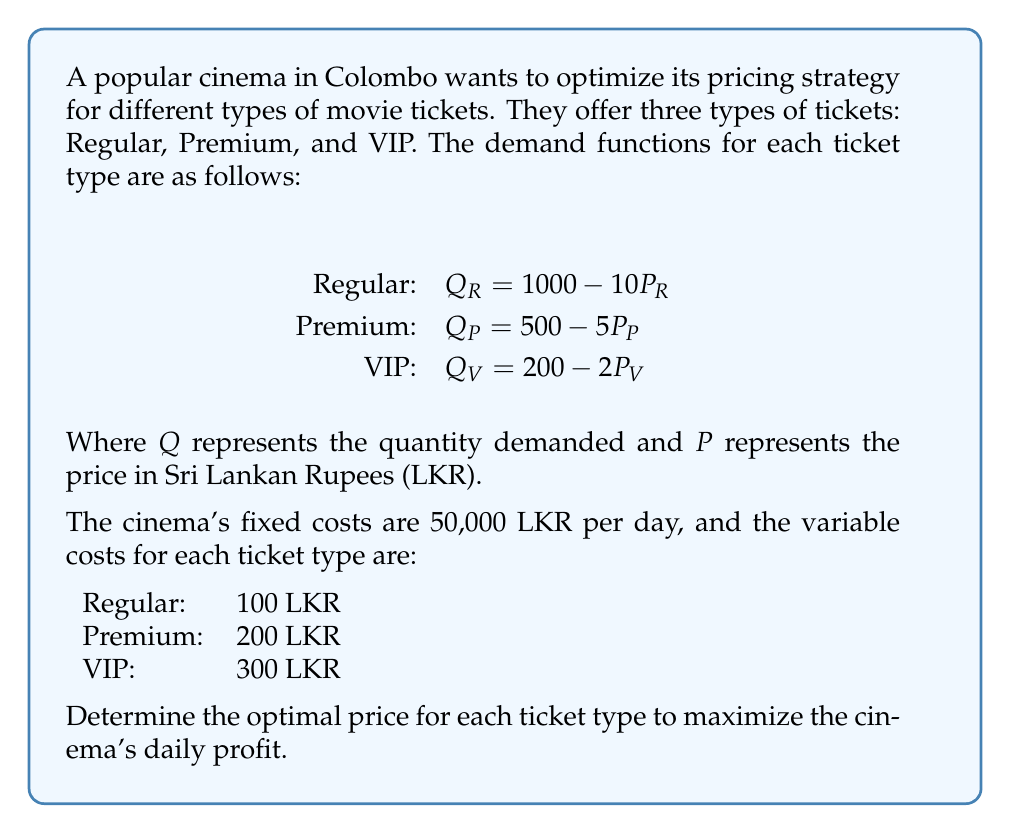Provide a solution to this math problem. To solve this problem, we'll follow these steps:

1. Set up the profit function
2. Find the revenue function for each ticket type
3. Calculate the total cost function
4. Derive the profit function
5. Find the optimal prices by maximizing the profit function

Step 1: Set up the profit function
Profit = Total Revenue - Total Cost

Step 2: Find the revenue function for each ticket type
Revenue = Price × Quantity

Regular: $R_R = P_R(1000 - 10P_R) = 1000P_R - 10P_R^2$
Premium: $R_P = P_P(500 - 5P_P) = 500P_P - 5P_P^2$
VIP: $R_V = P_V(200 - 2P_V) = 200P_V - 2P_V^2$

Total Revenue = $R_R + R_P + R_V$

Step 3: Calculate the total cost function
Total Cost = Fixed Cost + Variable Cost
Variable Cost = (Unit Cost × Quantity) for each ticket type

$TC = 50000 + 100(1000 - 10P_R) + 200(500 - 5P_P) + 300(200 - 2P_V)$

Step 4: Derive the profit function
$\pi = (1000P_R - 10P_R^2) + (500P_P - 5P_P^2) + (200P_V - 2P_V^2) - [50000 + 100(1000 - 10P_R) + 200(500 - 5P_P) + 300(200 - 2P_V)]$

Simplifying:
$\pi = -10P_R^2 + 2000P_R - 5P_P^2 + 1500P_P - 2P_V^2 + 800P_V - 250000$

Step 5: Find the optimal prices by maximizing the profit function
To maximize profit, we take partial derivatives with respect to each price and set them equal to zero:

$\frac{\partial \pi}{\partial P_R} = -20P_R + 2000 = 0$
$\frac{\partial \pi}{\partial P_P} = -10P_P + 1500 = 0$
$\frac{\partial \pi}{\partial P_V} = -4P_V + 800 = 0$

Solving these equations:

$P_R = 100$ LKR
$P_P = 150$ LKR
$P_V = 200$ LKR

To confirm these are maxima, we can check the second derivatives, which are all negative, confirming these prices maximize profit.
Answer: The optimal prices to maximize the cinema's daily profit are:

Regular tickets: 100 LKR
Premium tickets: 150 LKR
VIP tickets: 200 LKR 